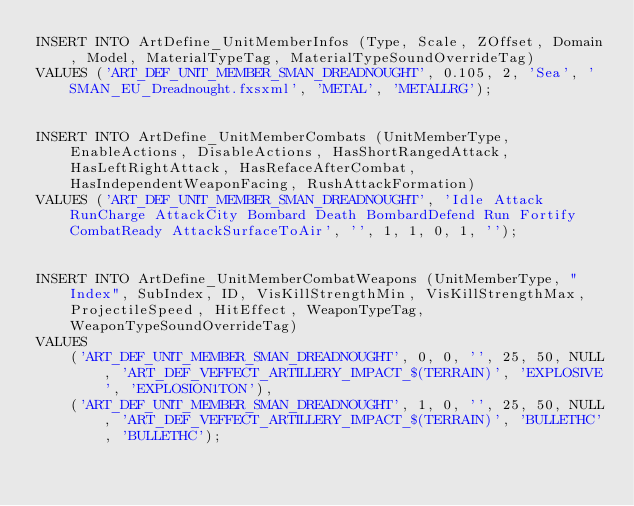Convert code to text. <code><loc_0><loc_0><loc_500><loc_500><_SQL_>INSERT INTO ArtDefine_UnitMemberInfos (Type, Scale, ZOffset, Domain, Model, MaterialTypeTag, MaterialTypeSoundOverrideTag)
VALUES ('ART_DEF_UNIT_MEMBER_SMAN_DREADNOUGHT', 0.105, 2, 'Sea', 'SMAN_EU_Dreadnought.fxsxml', 'METAL', 'METALLRG');


INSERT INTO ArtDefine_UnitMemberCombats (UnitMemberType, EnableActions, DisableActions,	HasShortRangedAttack, HasLeftRightAttack, HasRefaceAfterCombat, HasIndependentWeaponFacing, RushAttackFormation)
VALUES ('ART_DEF_UNIT_MEMBER_SMAN_DREADNOUGHT', 'Idle Attack RunCharge AttackCity Bombard Death BombardDefend Run Fortify CombatReady AttackSurfaceToAir', '', 1, 1, 0, 1, '');


INSERT INTO ArtDefine_UnitMemberCombatWeapons (UnitMemberType, "Index", SubIndex, ID, VisKillStrengthMin, VisKillStrengthMax, ProjectileSpeed, HitEffect, WeaponTypeTag, WeaponTypeSoundOverrideTag)
VALUES 
	('ART_DEF_UNIT_MEMBER_SMAN_DREADNOUGHT', 0, 0, '', 25, 50, NULL, 'ART_DEF_VEFFECT_ARTILLERY_IMPACT_$(TERRAIN)', 'EXPLOSIVE', 'EXPLOSION1TON'),
	('ART_DEF_UNIT_MEMBER_SMAN_DREADNOUGHT', 1, 0, '', 25, 50, NULL, 'ART_DEF_VEFFECT_ARTILLERY_IMPACT_$(TERRAIN)', 'BULLETHC', 'BULLETHC');
</code> 